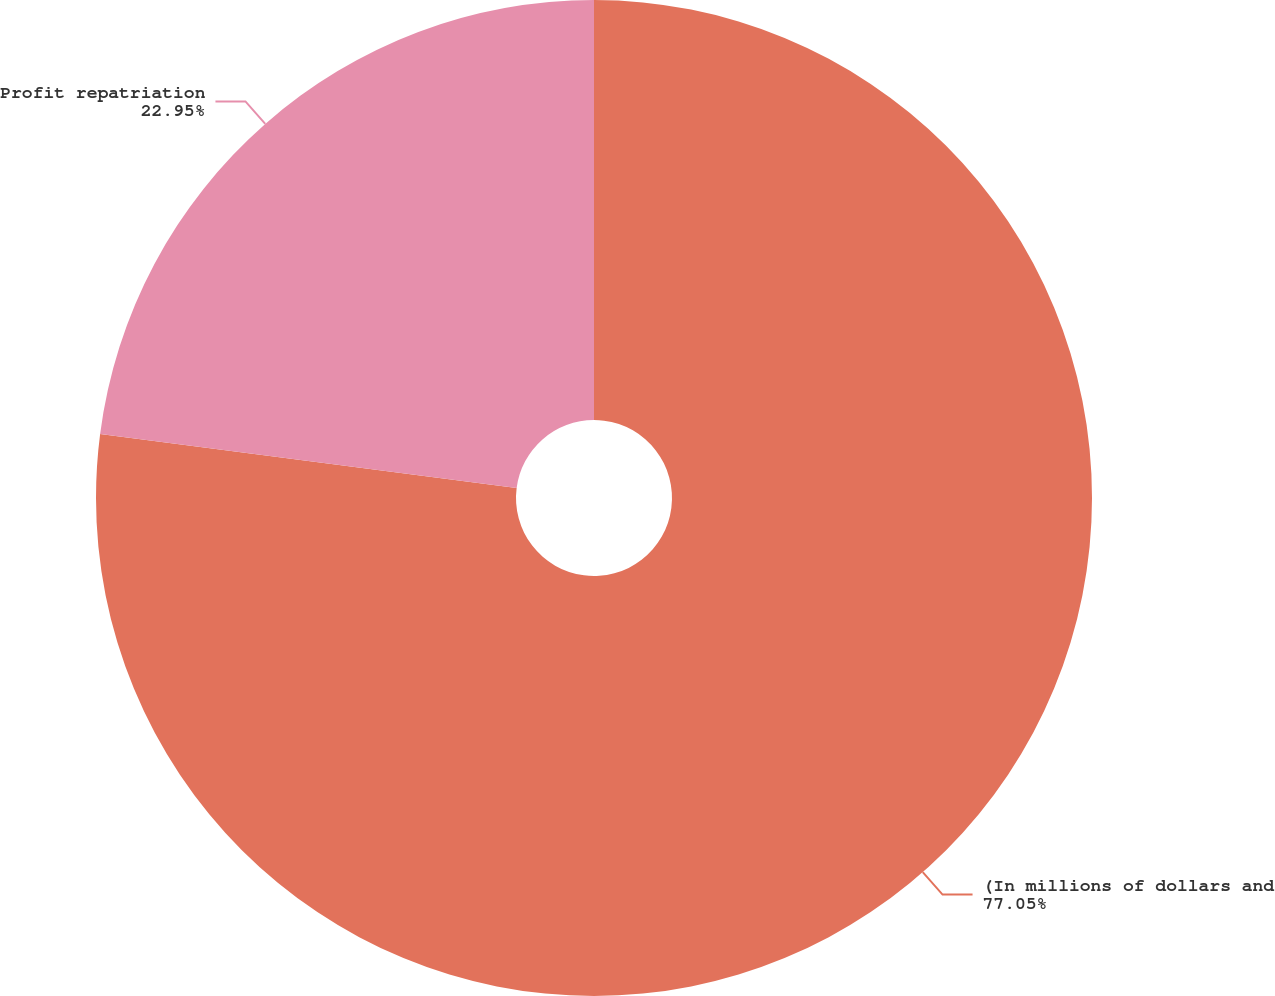Convert chart to OTSL. <chart><loc_0><loc_0><loc_500><loc_500><pie_chart><fcel>(In millions of dollars and<fcel>Profit repatriation<nl><fcel>77.05%<fcel>22.95%<nl></chart> 